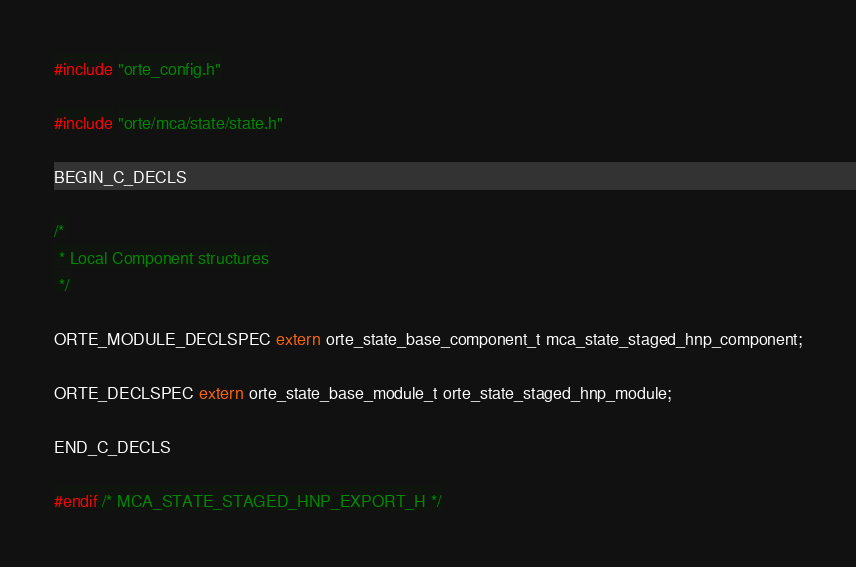<code> <loc_0><loc_0><loc_500><loc_500><_C_>
#include "orte_config.h"

#include "orte/mca/state/state.h"

BEGIN_C_DECLS

/*
 * Local Component structures
 */

ORTE_MODULE_DECLSPEC extern orte_state_base_component_t mca_state_staged_hnp_component;

ORTE_DECLSPEC extern orte_state_base_module_t orte_state_staged_hnp_module;

END_C_DECLS

#endif /* MCA_STATE_STAGED_HNP_EXPORT_H */
</code> 